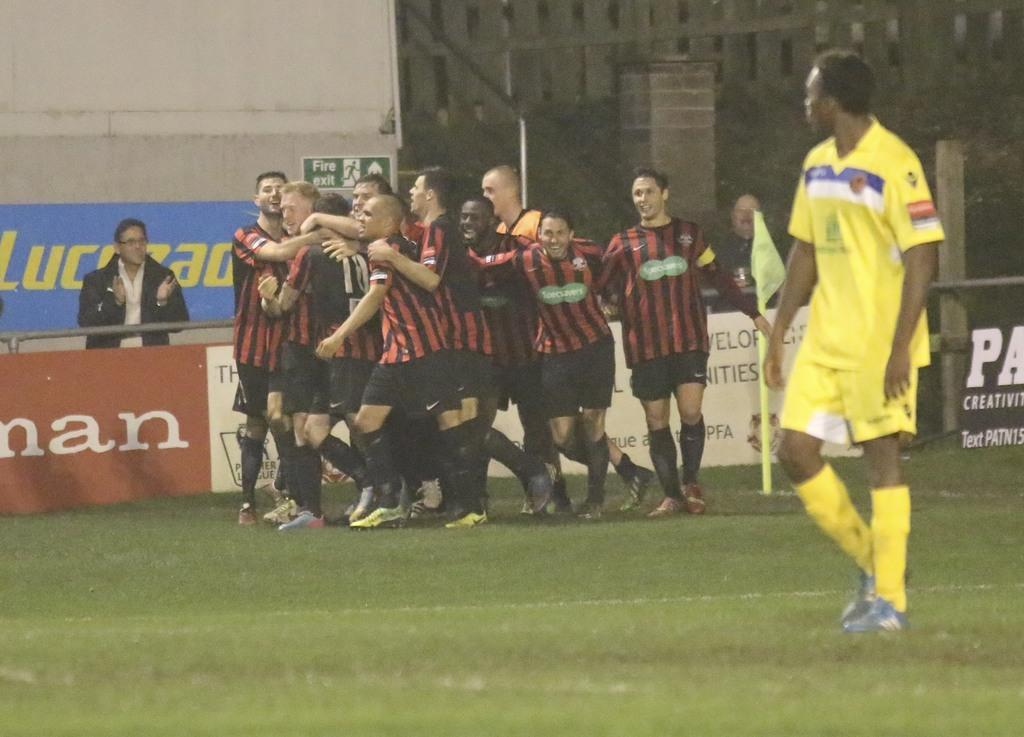Provide a one-sentence caption for the provided image. A crowd of players is right near the little green for the fire exit. 